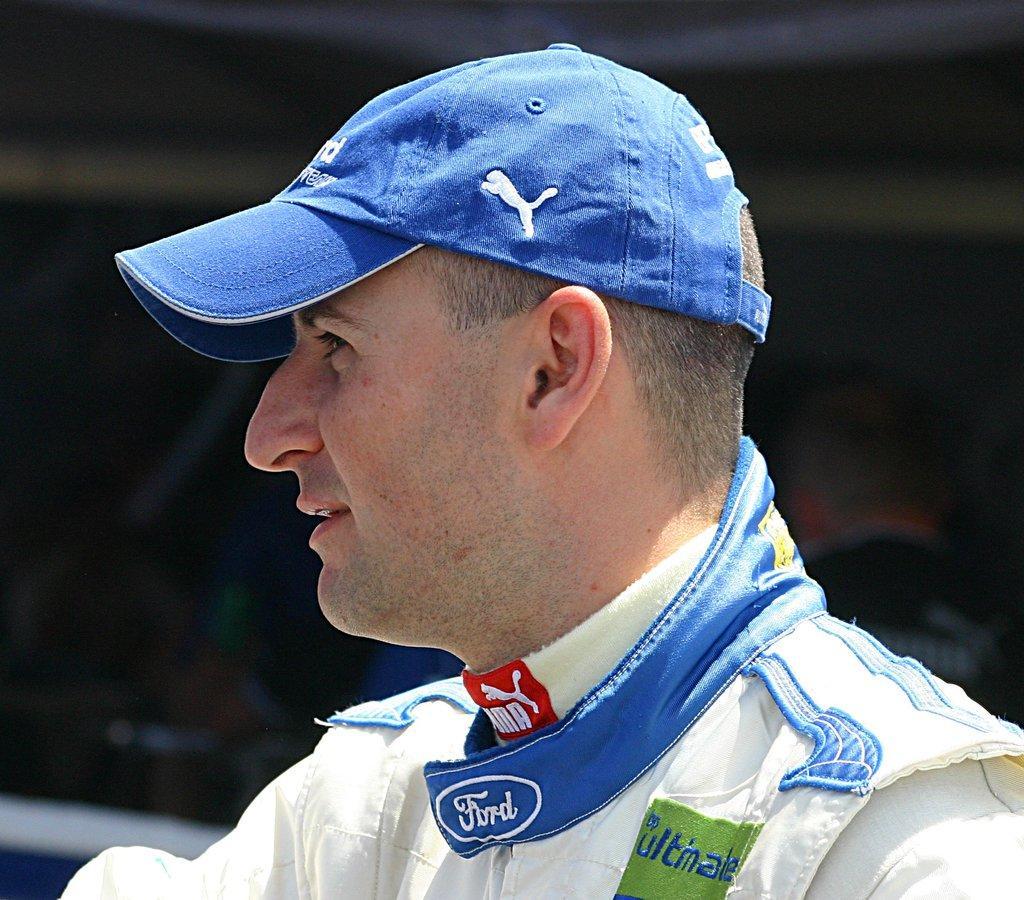Can you describe this image briefly? In this picture there is a man wore cap. In the background of the image it is blurry. 